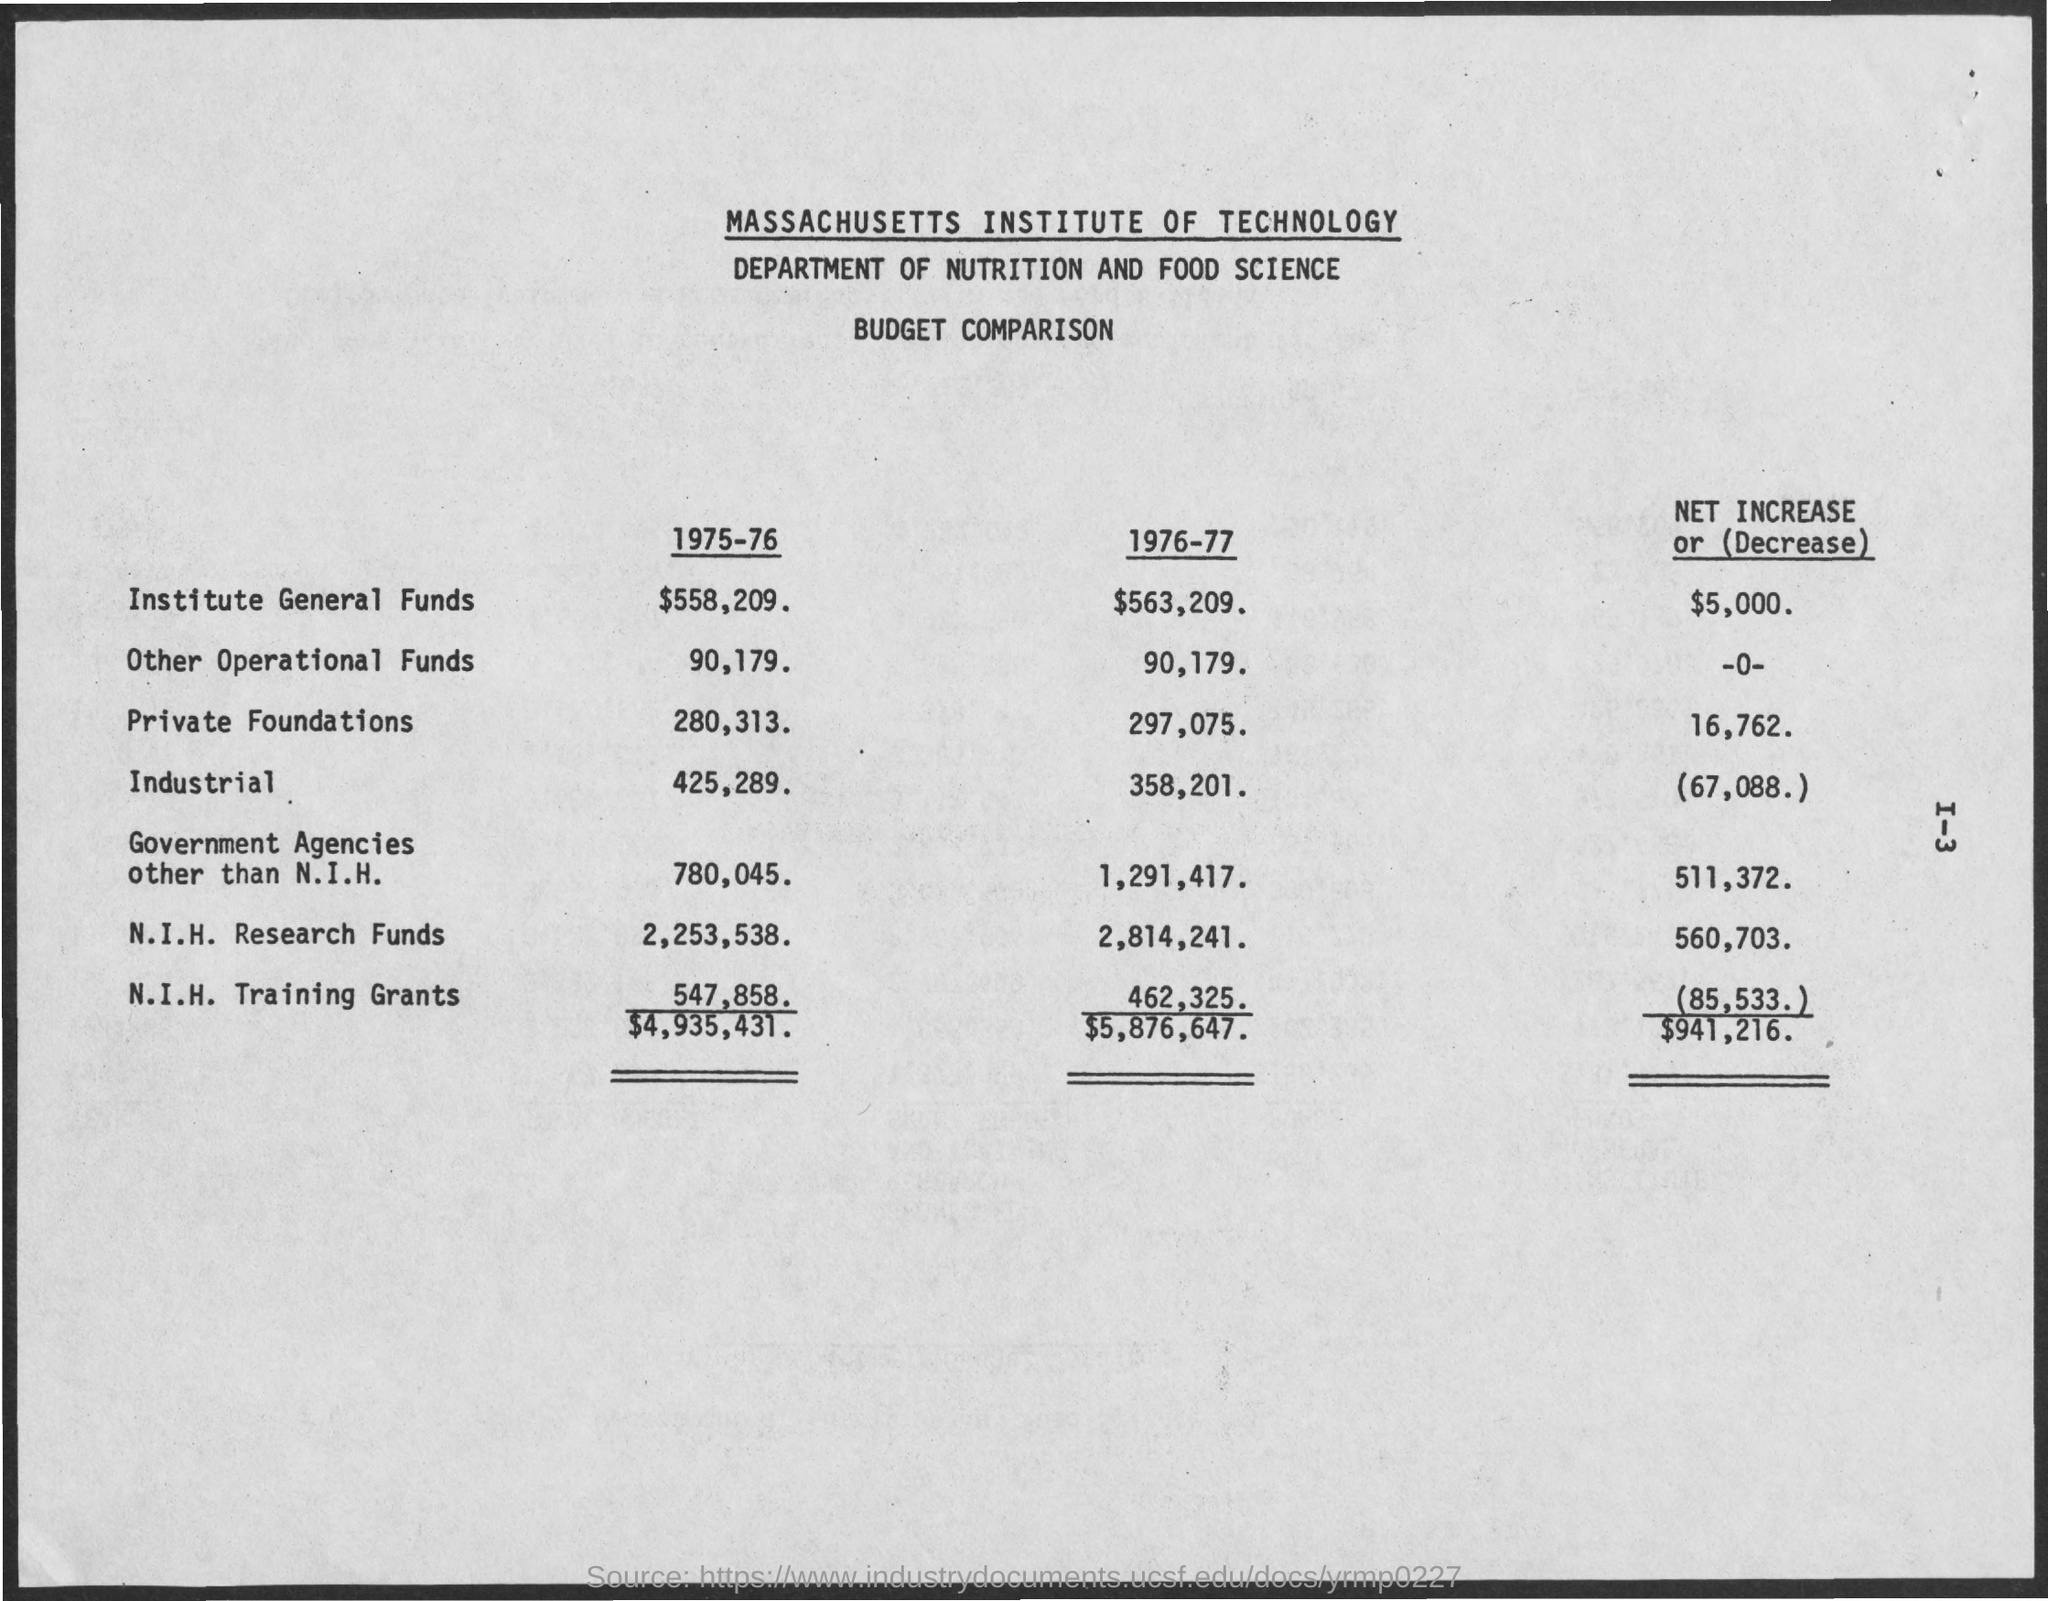What is the N.I.H. Research Funds for 1976-77? For the fiscal year 1976-77, the National Institutes of Health (N.I.H.) Research Funds allocated to the Massachusetts Institute of Technology's Department of Nutrition and Food Science amounted to $2,814,241, reflecting an increase of $560,703 from the previous year. 